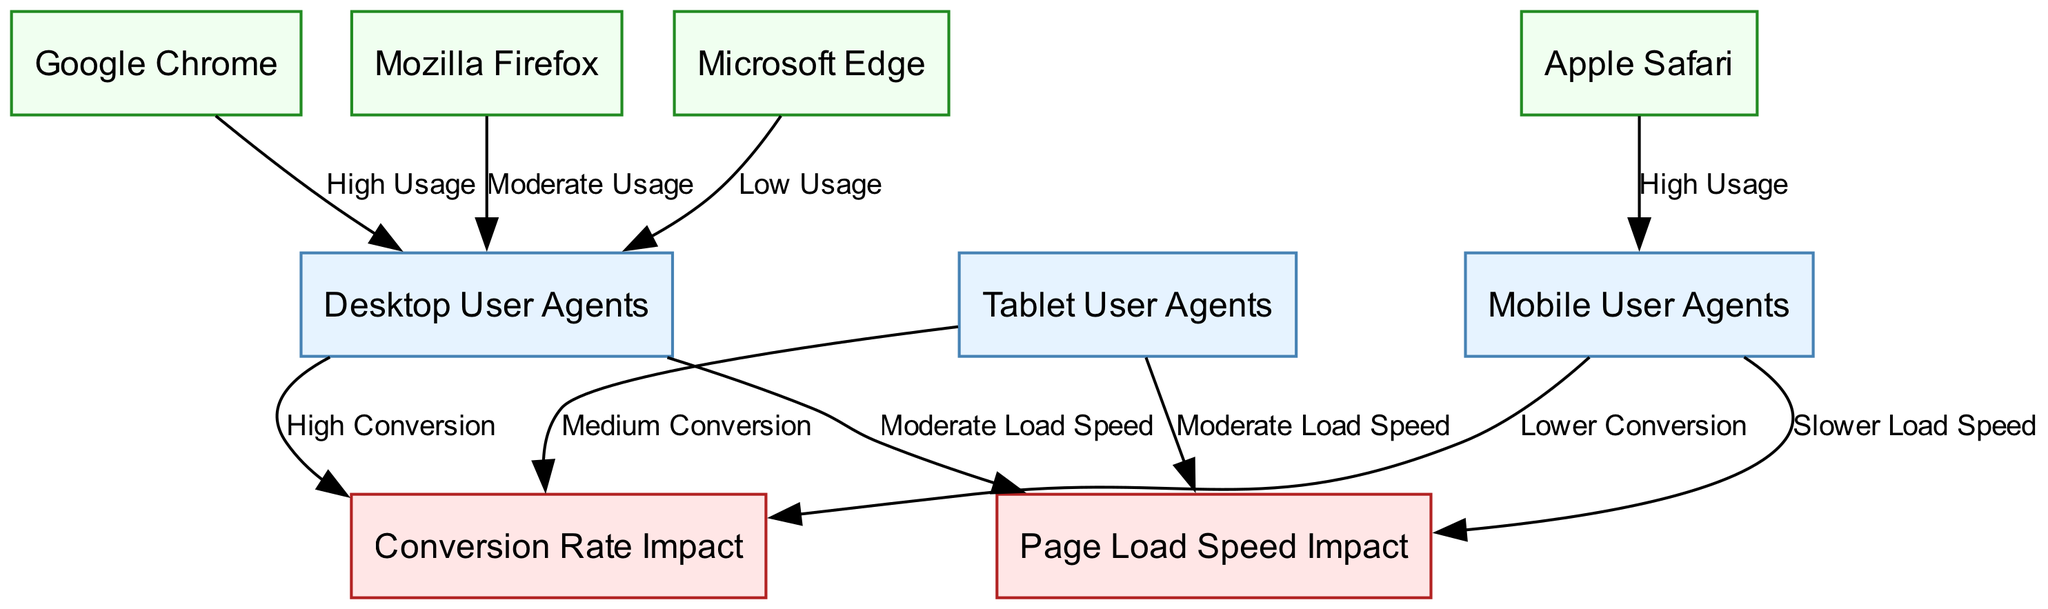What types of user agents are represented in the diagram? The nodes in the diagram include "Desktop User Agents", "Mobile User Agents", and "Tablet User Agents", which clearly indicate the types of user agents being analyzed.
Answer: Desktop User Agents, Mobile User Agents, Tablet User Agents Which user agent type has a lower conversion rate impact? The diagram indicates that "Mobile User Agents" have a label stating "Lower Conversion", while the other types have higher conversion impacts, thus indicating that Mobile user agents negatively impact conversion rates comparatively.
Answer: Mobile User Agents How many edges are present in the diagram? By counting the connections represented by arrows in the diagram, we see there are a total of eight edges linking various user agents and their impacts on page load speed and conversion rates.
Answer: Eight What is the impact of Desktop User Agents on page load speed? According to the edge leading from "Desktop User Agents" to "Page Load Speed Impact", the label states "Moderate Load Speed", indicating the load speed effect attributed to this user agent type.
Answer: Moderate Load Speed Which browser has high usage associated with Mobile User Agents? The diagram shows that "Apple Safari" connects with "Mobile User Agents" and carries the label "High Usage", indicating that this browser type is predominantly used for mobile access.
Answer: Apple Safari What is the conversion rate impact associated with Tablet User Agents? The edge from "Tablet User Agents" to "Conversion Rate Impact" is labeled "Medium Conversion", indicating the impact level on conversion rates for this type of user agent.
Answer: Medium Conversion Which browser has the lowest usage among Desktop User Agents? The connection between "Microsoft Edge" and "Desktop User Agents" has the label "Low Usage", indicating that this browser is less common among desktop users according to the diagram.
Answer: Microsoft Edge What is the overall impact of Mobile User Agents on page load speed? The edge from "Mobile User Agents" to "Page Load Speed Impact" indicates "Slower Load Speed", thereby showing that this user agent type overall negatively impacts load speed.
Answer: Slower Load Speed 